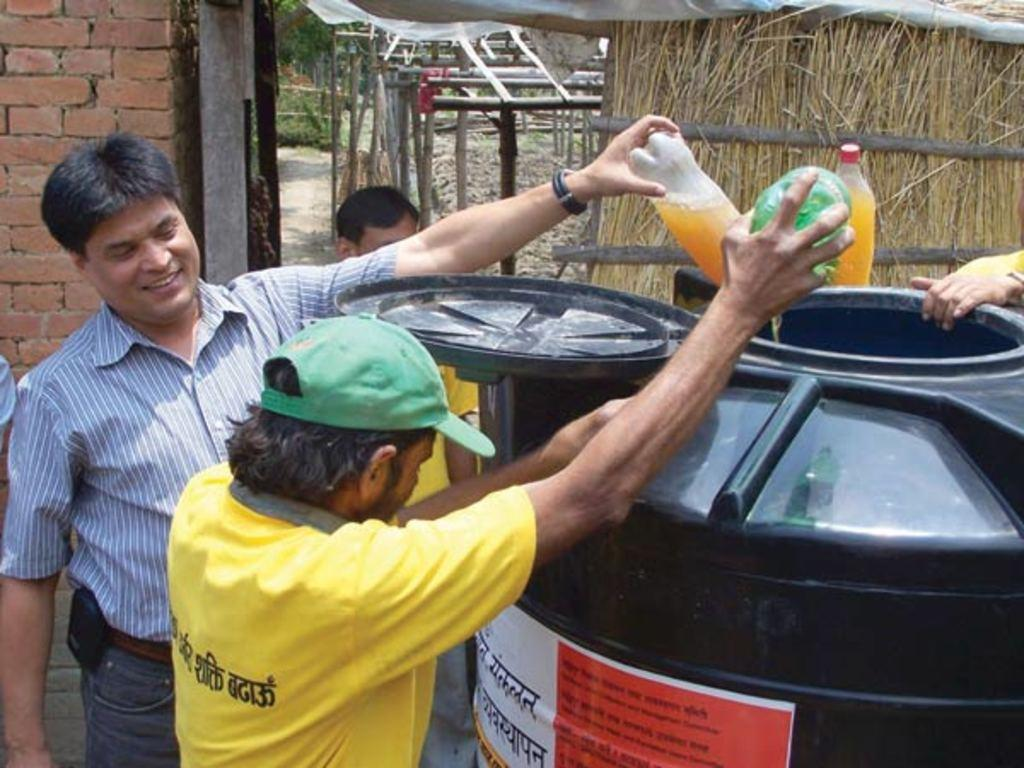How many people are in the image? There is a group of persons in the image. What are the persons in the image doing? The group of persons is pouring a drink. Can you identify any objects in the image besides the persons? Yes, there is a drum in the image. What type of debt is being discussed by the group of persons in the image? There is no mention of debt in the image; the group of persons is pouring a drink. Can you see any members of the army in the image? There is no indication of any army members in the image. 